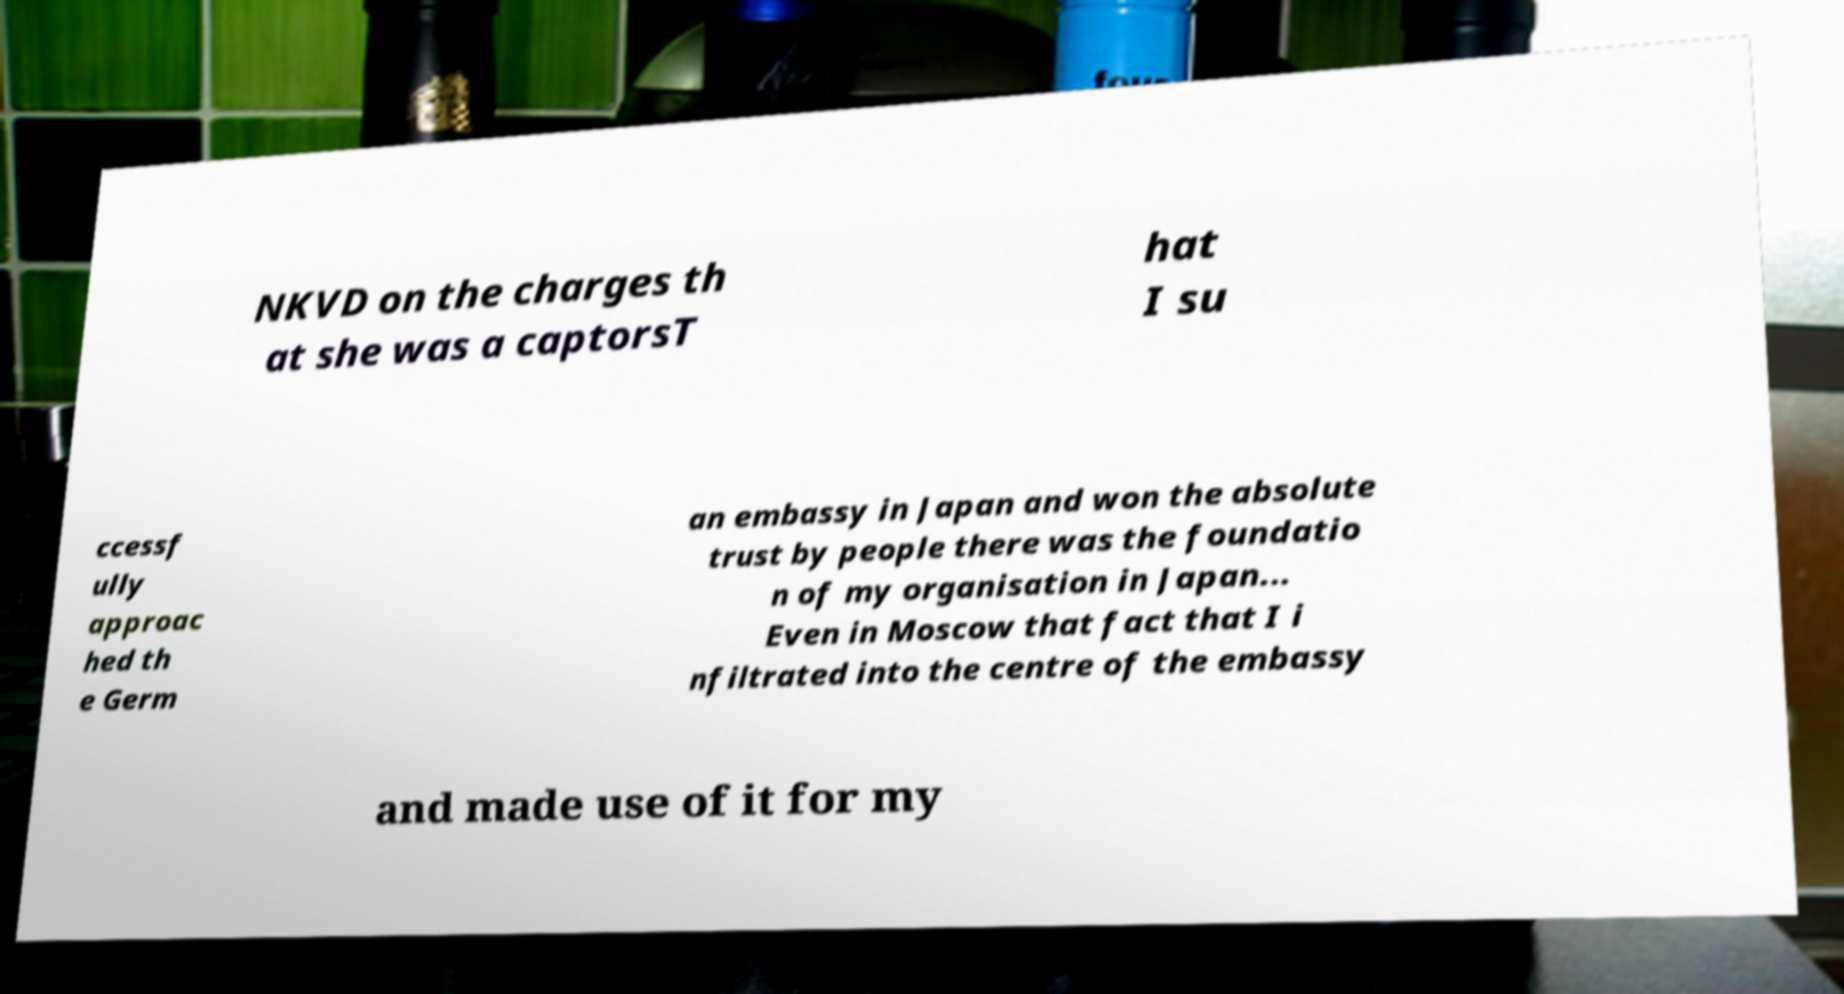Could you extract and type out the text from this image? NKVD on the charges th at she was a captorsT hat I su ccessf ully approac hed th e Germ an embassy in Japan and won the absolute trust by people there was the foundatio n of my organisation in Japan... Even in Moscow that fact that I i nfiltrated into the centre of the embassy and made use of it for my 